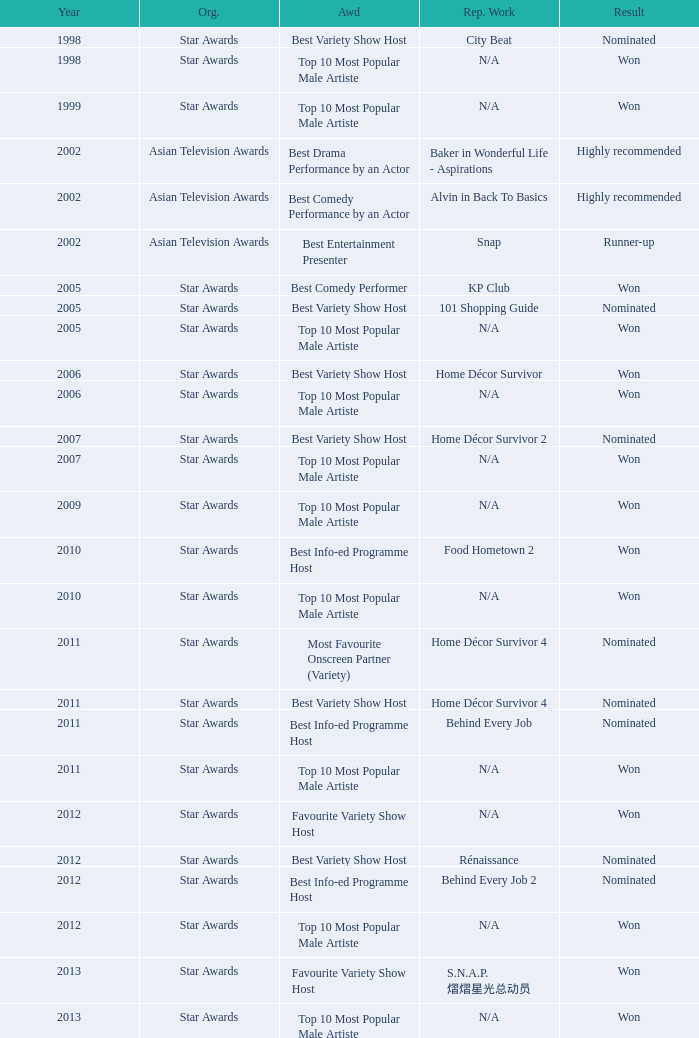What is the name of the award in a year more than 2005, and the Result of nominated? Best Variety Show Host, Most Favourite Onscreen Partner (Variety), Best Variety Show Host, Best Info-ed Programme Host, Best Variety Show Host, Best Info-ed Programme Host, Best Info-Ed Programme Host, Best Variety Show Host. 